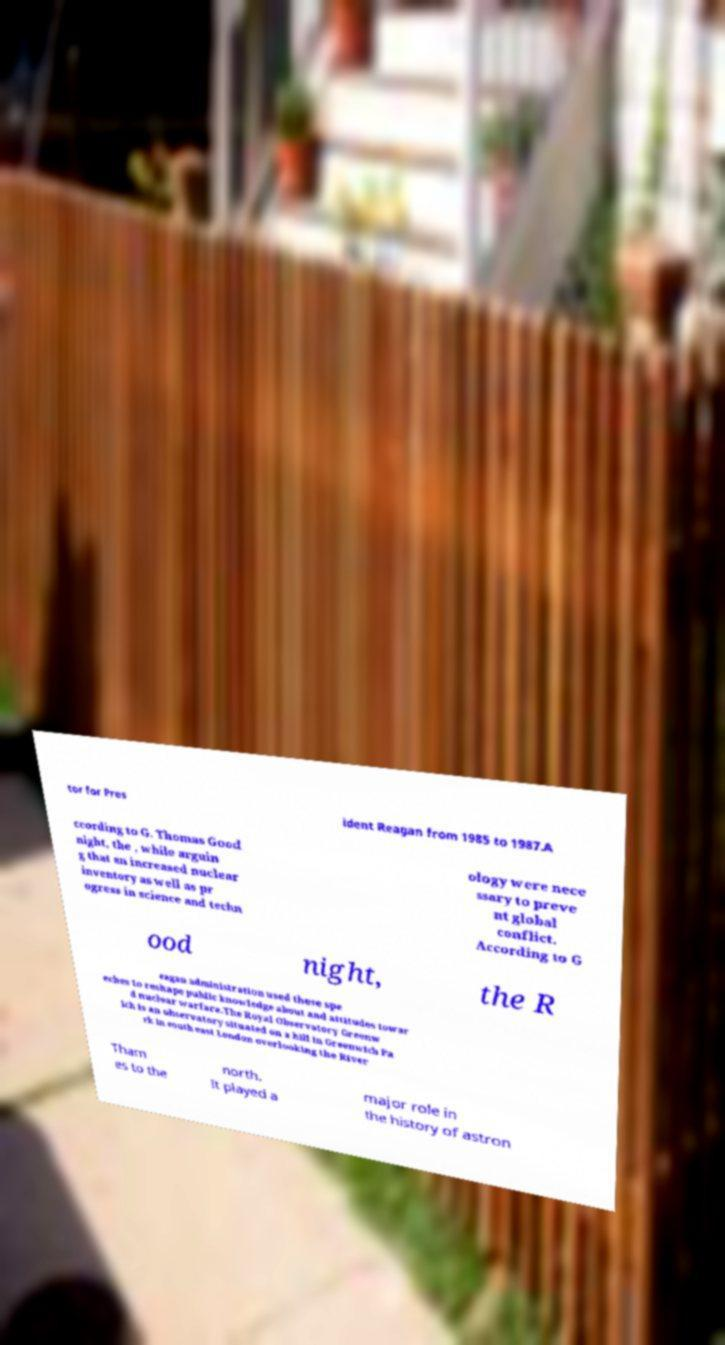I need the written content from this picture converted into text. Can you do that? tor for Pres ident Reagan from 1985 to 1987.A ccording to G. Thomas Good night, the , while arguin g that an increased nuclear inventory as well as pr ogress in science and techn ology were nece ssary to preve nt global conflict. According to G ood night, the R eagan administration used these spe eches to reshape public knowledge about and attitudes towar d nuclear warfare.The Royal Observatory Greenw ich is an observatory situated on a hill in Greenwich Pa rk in south east London overlooking the River Tham es to the north. It played a major role in the history of astron 